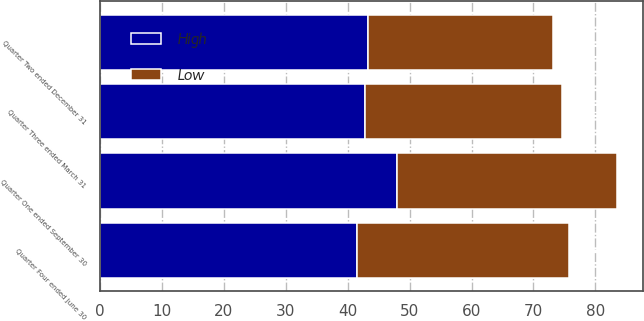Convert chart. <chart><loc_0><loc_0><loc_500><loc_500><stacked_bar_chart><ecel><fcel>Quarter One ended September 30<fcel>Quarter Two ended December 31<fcel>Quarter Three ended March 31<fcel>Quarter Four ended June 30<nl><fcel>High<fcel>47.98<fcel>43.35<fcel>42.81<fcel>41.56<nl><fcel>Low<fcel>35.53<fcel>29.83<fcel>31.82<fcel>34.19<nl></chart> 